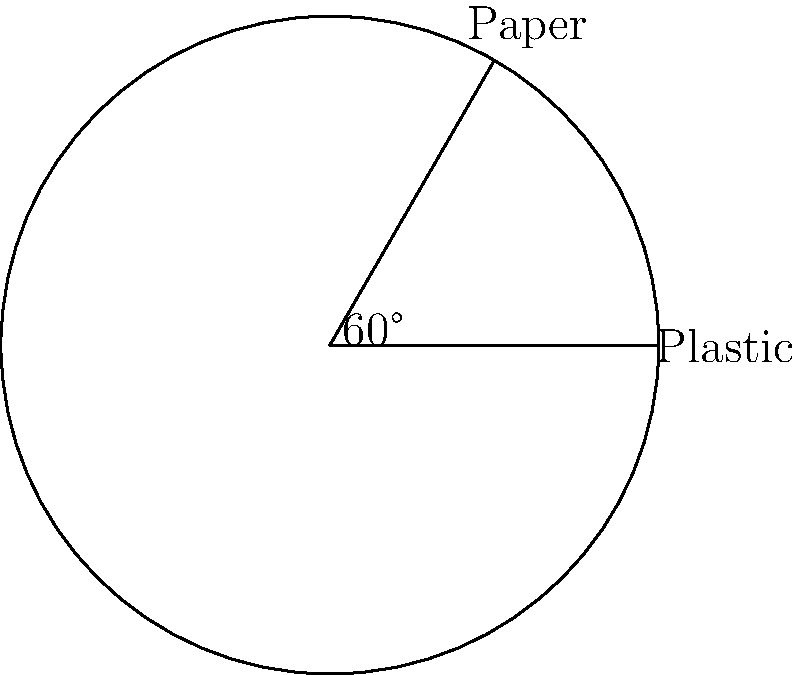A pie chart representing recycling statistics in Denmark shows that plastic waste accounts for a 60° sector. If the radius of the chart is 10 cm, calculate the area of the sector representing plastic waste. Round your answer to the nearest square centimeter. To solve this problem, we'll use the formula for the area of a sector:

$$ A = \frac{\theta}{360°} \pi r^2 $$

Where:
$A$ = Area of the sector
$\theta$ = Central angle in degrees
$r$ = Radius of the circle

Step 1: Identify the given values
$\theta = 60°$
$r = 10$ cm

Step 2: Substitute these values into the formula
$$ A = \frac{60°}{360°} \pi (10\text{ cm})^2 $$

Step 3: Simplify the fraction
$$ A = \frac{1}{6} \pi (100\text{ cm}^2) $$

Step 4: Calculate
$$ A = \frac{1}{6} \pi 100\text{ cm}^2 = \frac{100\pi}{6}\text{ cm}^2 \approx 52.36\text{ cm}^2 $$

Step 5: Round to the nearest square centimeter
$52.36\text{ cm}^2$ rounds to $52\text{ cm}^2$
Answer: $52\text{ cm}^2$ 